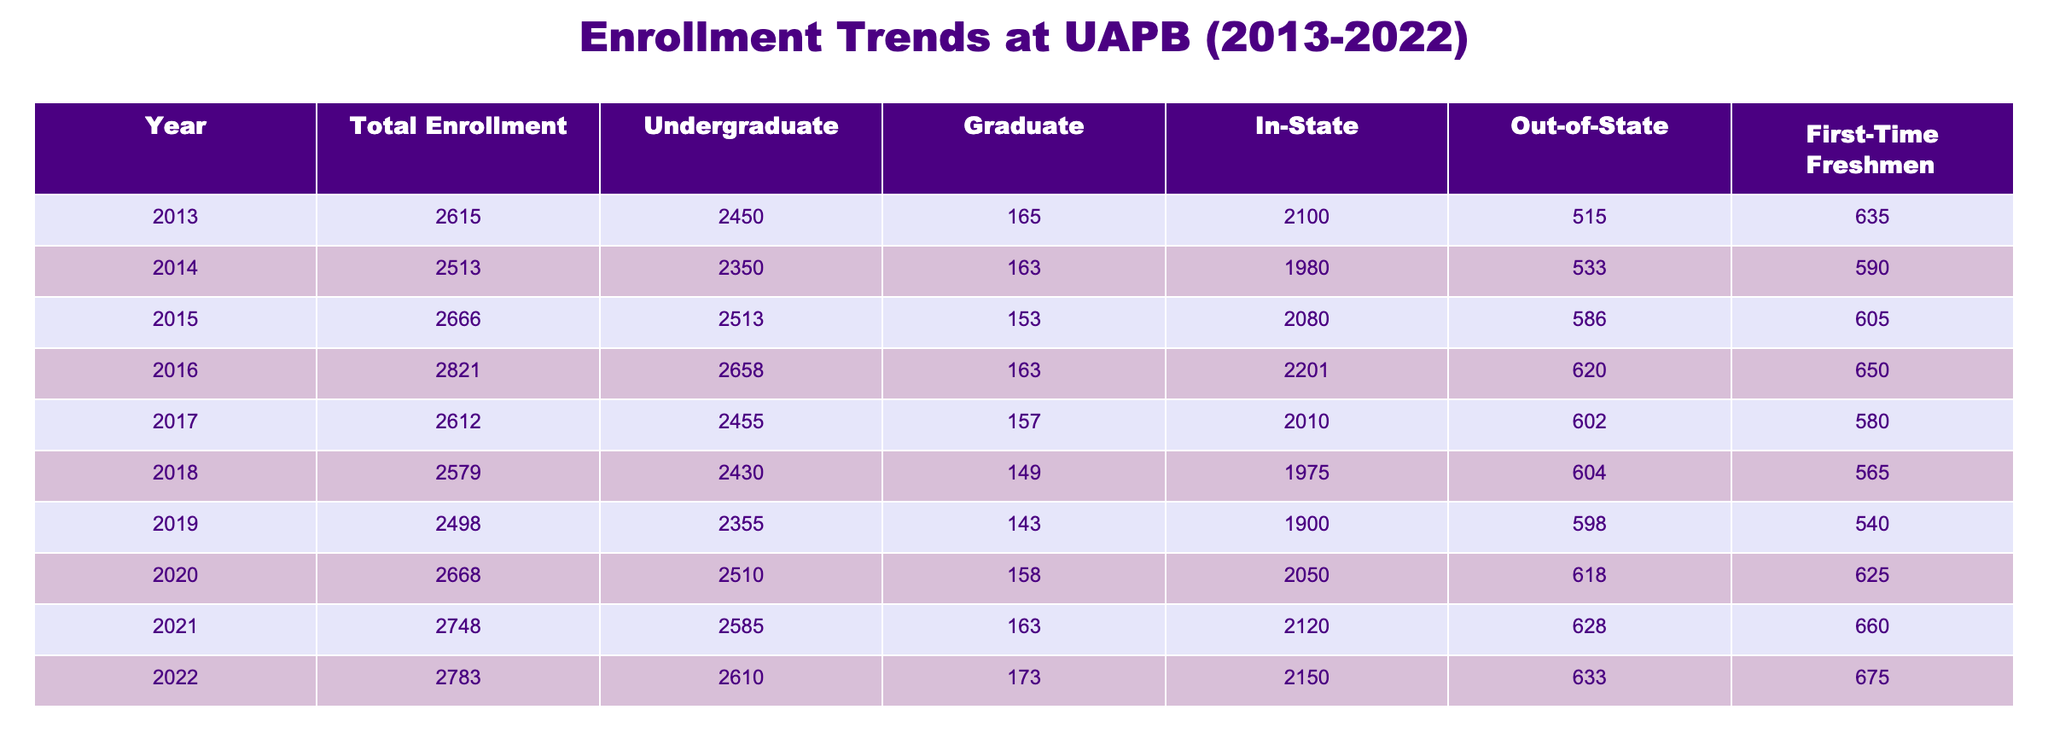What was the total enrollment at UAPB in 2016? From the table, the total enrollment for the year 2016 is directly listed as 2821.
Answer: 2821 What is the percentage of undergraduate students in the total enrollment for 2021? In 2021, the total enrollment is 2748, and the number of undergraduate students is 2585. The percentage is calculated as (2585/2748) * 100, which is approximately 94.1%.
Answer: 94.1% What was the enrollment trend from 2013 to 2022? Looking at the total enrollment figures from the years 2013 (2615) to 2022 (2783), we see fluctuations, but generally, the trend is upwards with an increase of 168 students over this period.
Answer: Upward trend Was the number of out-of-state students higher in 2015 or 2022? In 2015, there were 586 out-of-state students, while in 2022, there were 633. Therefore, the number in 2022 is higher than in 2015.
Answer: Yes What is the average number of first-time freshmen over the last decade? The first-time freshmen numbers from 2013 to 2022 are 635, 590, 605, 650, 580, 565, 540, 625, 660, and 675. The average is calculated by summing these values (635 + 590 + 605 + 650 + 580 + 565 + 540 + 625 + 660 + 675 = 5850) and dividing by the number of years (10), resulting in an average of 585.
Answer: 585 How many more in-state students were there in 2020 compared to 2018? In 2020, there were 2050 in-state students and in 2018, there were 1975 in-state students. The difference is 2050 - 1975 = 75 more in-state students in 2020.
Answer: 75 more What was the maximum total enrollment recorded in the last decade? The maximum total enrollment was in 2022 with 2783 students, which can be identified by comparing all the total enrollment figures from 2013 to 2022.
Answer: 2783 Was there an increase in the number of graduate students from 2019 to 2021? In 2019, there were 143 graduate students, and in 2021, there were 163. Thus, there was an increase of 20 graduate students between these two years.
Answer: Yes 